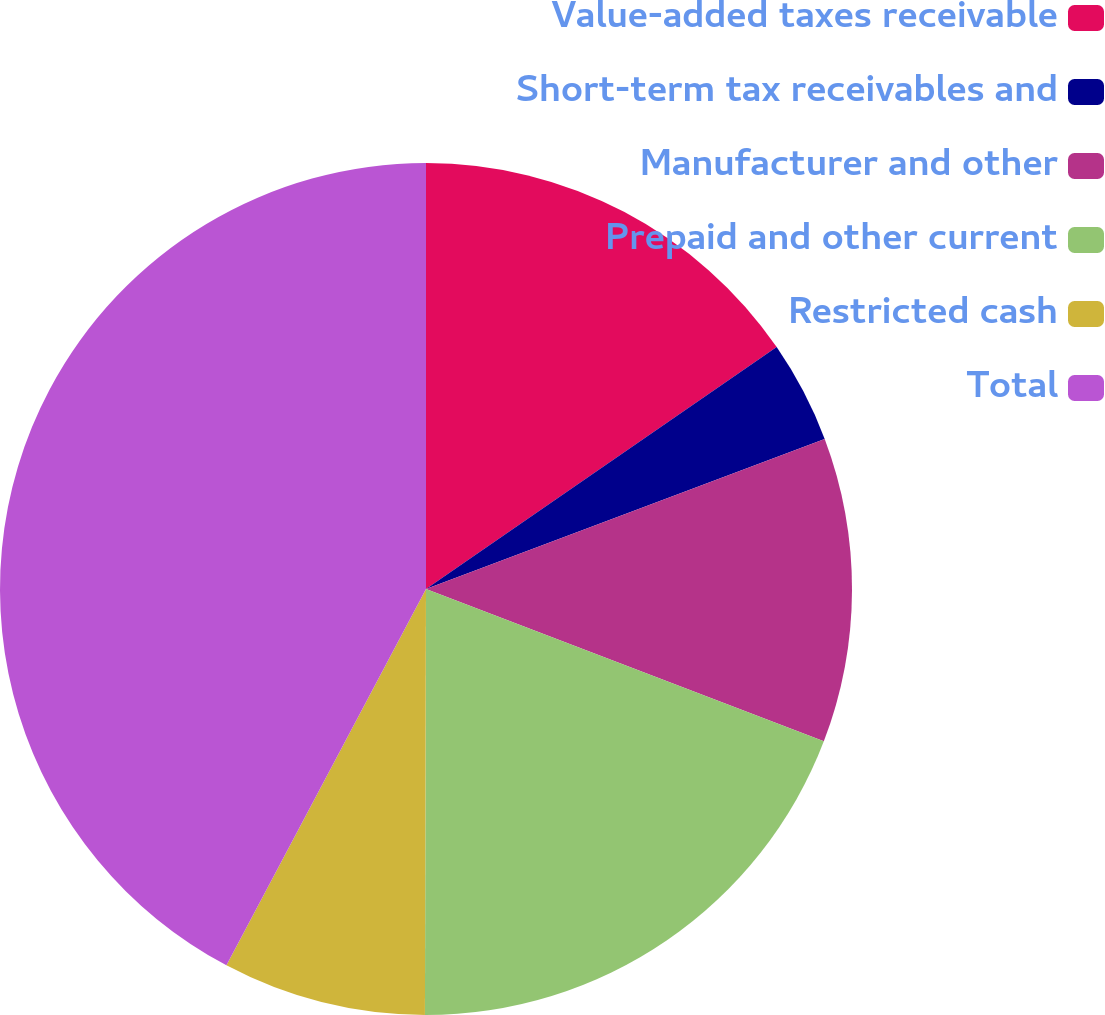Convert chart. <chart><loc_0><loc_0><loc_500><loc_500><pie_chart><fcel>Value-added taxes receivable<fcel>Short-term tax receivables and<fcel>Manufacturer and other<fcel>Prepaid and other current<fcel>Restricted cash<fcel>Total<nl><fcel>15.39%<fcel>3.88%<fcel>11.55%<fcel>19.22%<fcel>7.72%<fcel>42.24%<nl></chart> 